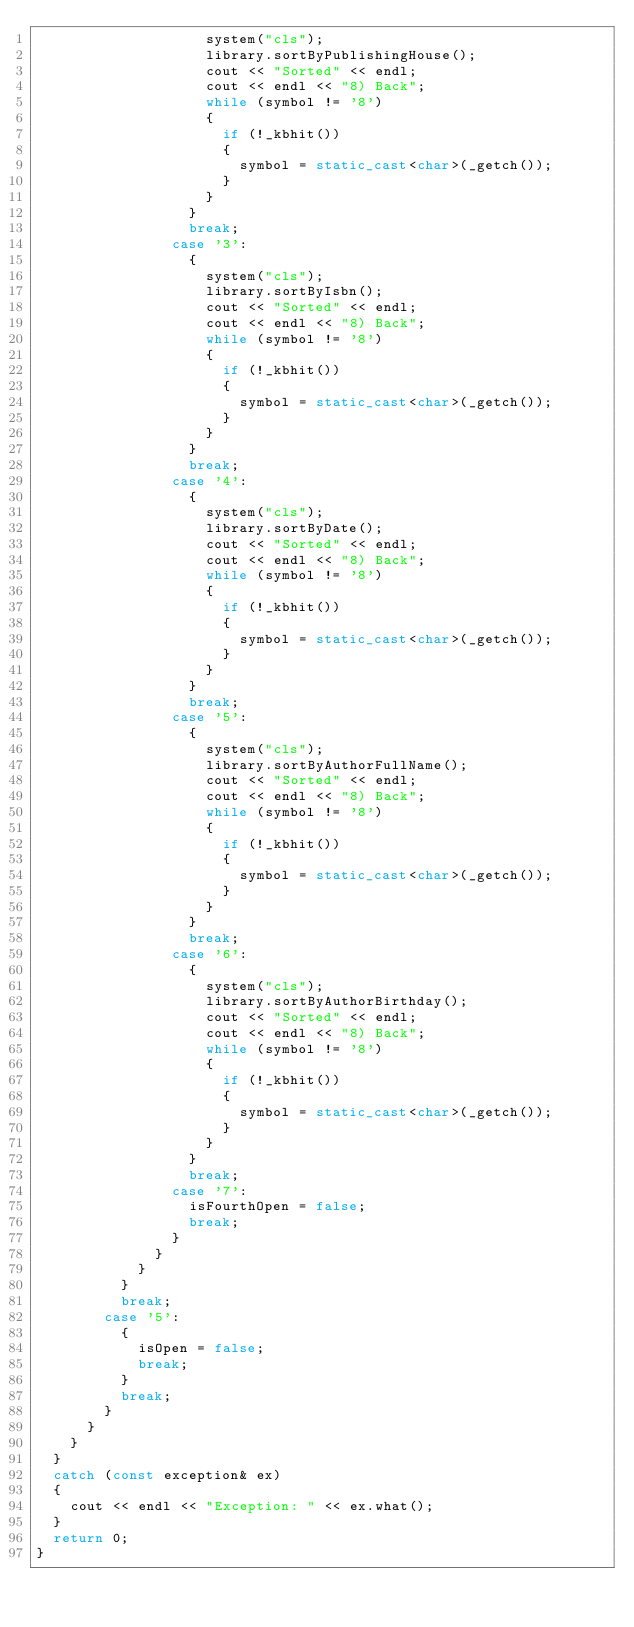Convert code to text. <code><loc_0><loc_0><loc_500><loc_500><_C++_>										system("cls");
										library.sortByPublishingHouse();
										cout << "Sorted" << endl;
										cout << endl << "8) Back";
										while (symbol != '8')
										{
											if (!_kbhit())
											{
												symbol = static_cast<char>(_getch());
											}
										}
									}
									break;
								case '3':
									{
										system("cls");
										library.sortByIsbn();
										cout << "Sorted" << endl;
										cout << endl << "8) Back";
										while (symbol != '8')
										{
											if (!_kbhit())
											{
												symbol = static_cast<char>(_getch());
											}
										}
									}
									break;
								case '4':
									{
										system("cls");
										library.sortByDate();
										cout << "Sorted" << endl;
										cout << endl << "8) Back";
										while (symbol != '8')
										{
											if (!_kbhit())
											{
												symbol = static_cast<char>(_getch());
											}
										}
									}
									break;
								case '5':
									{
										system("cls");
										library.sortByAuthorFullName();
										cout << "Sorted" << endl;
										cout << endl << "8) Back";
										while (symbol != '8')
										{
											if (!_kbhit())
											{
												symbol = static_cast<char>(_getch());
											}
										}
									}
									break;
								case '6':
									{
										system("cls");
										library.sortByAuthorBirthday();
										cout << "Sorted" << endl;
										cout << endl << "8) Back";
										while (symbol != '8')
										{
											if (!_kbhit())
											{
												symbol = static_cast<char>(_getch());
											}
										}
									}
									break;
								case '7':
									isFourthOpen = false;
									break;
								}
							}
						}
					}
					break;
				case '5':
					{
						isOpen = false;
						break;
					}
					break;
				}
			}
		}
	}
	catch (const exception& ex)
	{
		cout << endl << "Exception: " << ex.what();
	}
	return 0;
}
</code> 